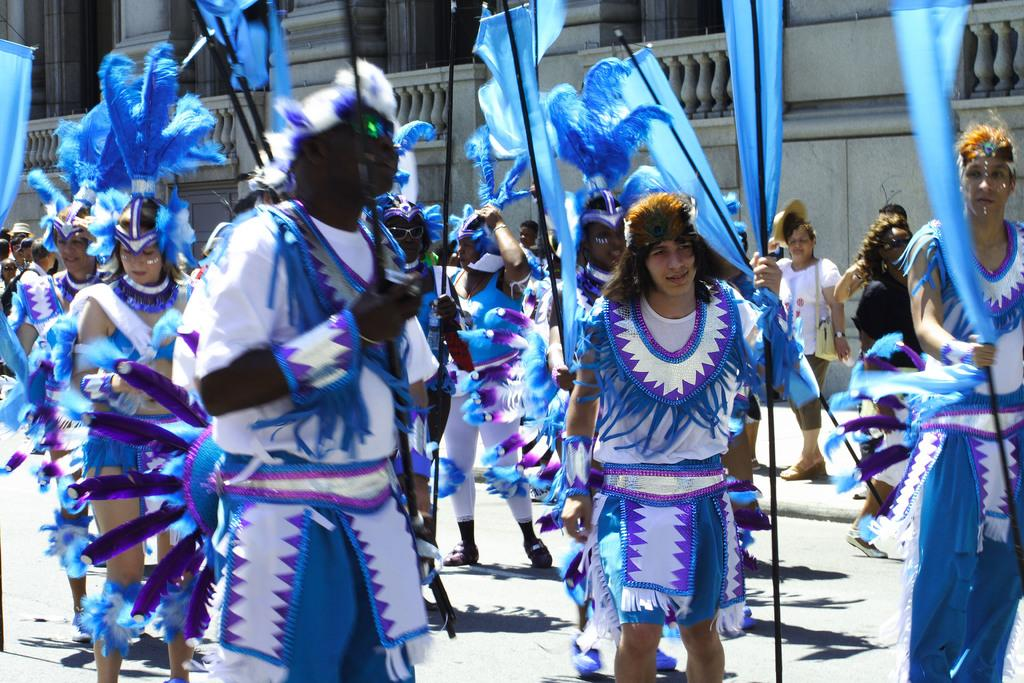What color combination is worn by the persons in the image? The persons in the image are wearing a white and blue color combination. What are the persons holding in the image? The persons are holding sticks. Where does the scene take place? The scene takes place on a road. What else can be seen in the background of the image? There are other persons and a building visible in the background of the image. Can you see a wilderness area in the image? No, there is no wilderness area visible in the image. The scene takes place on a road, as mentioned in the conversation. 